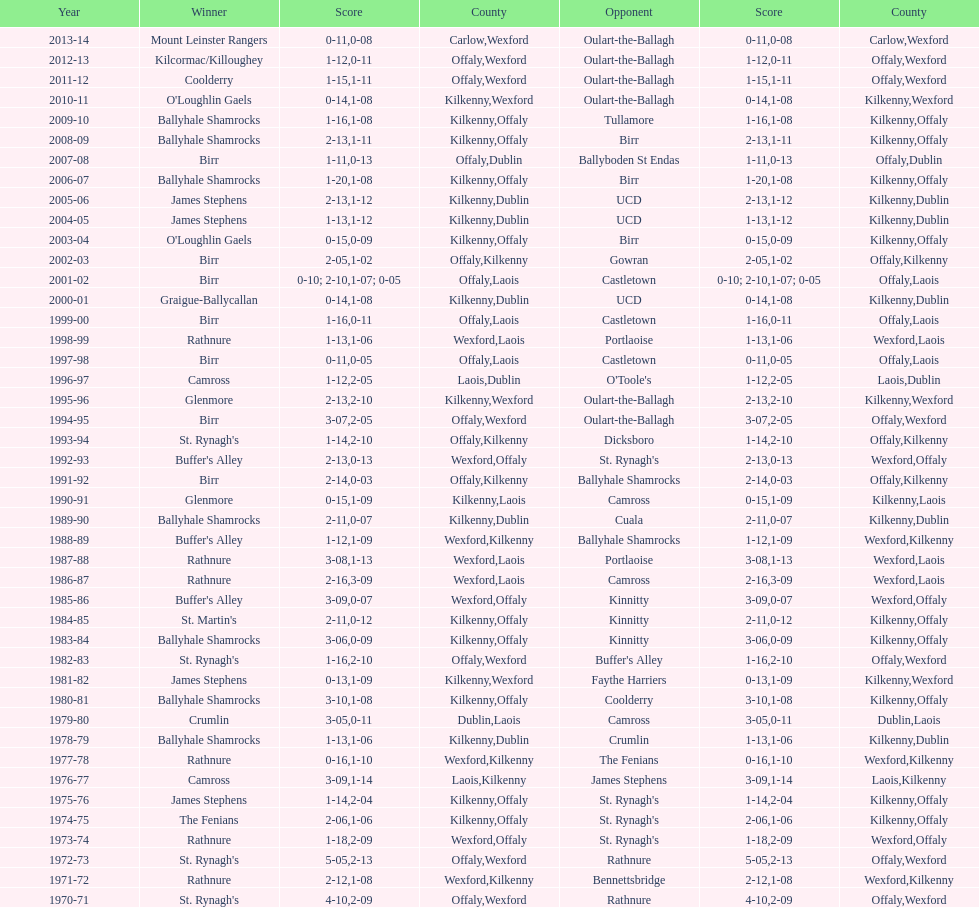How many consecutive years did rathnure win? 2. 